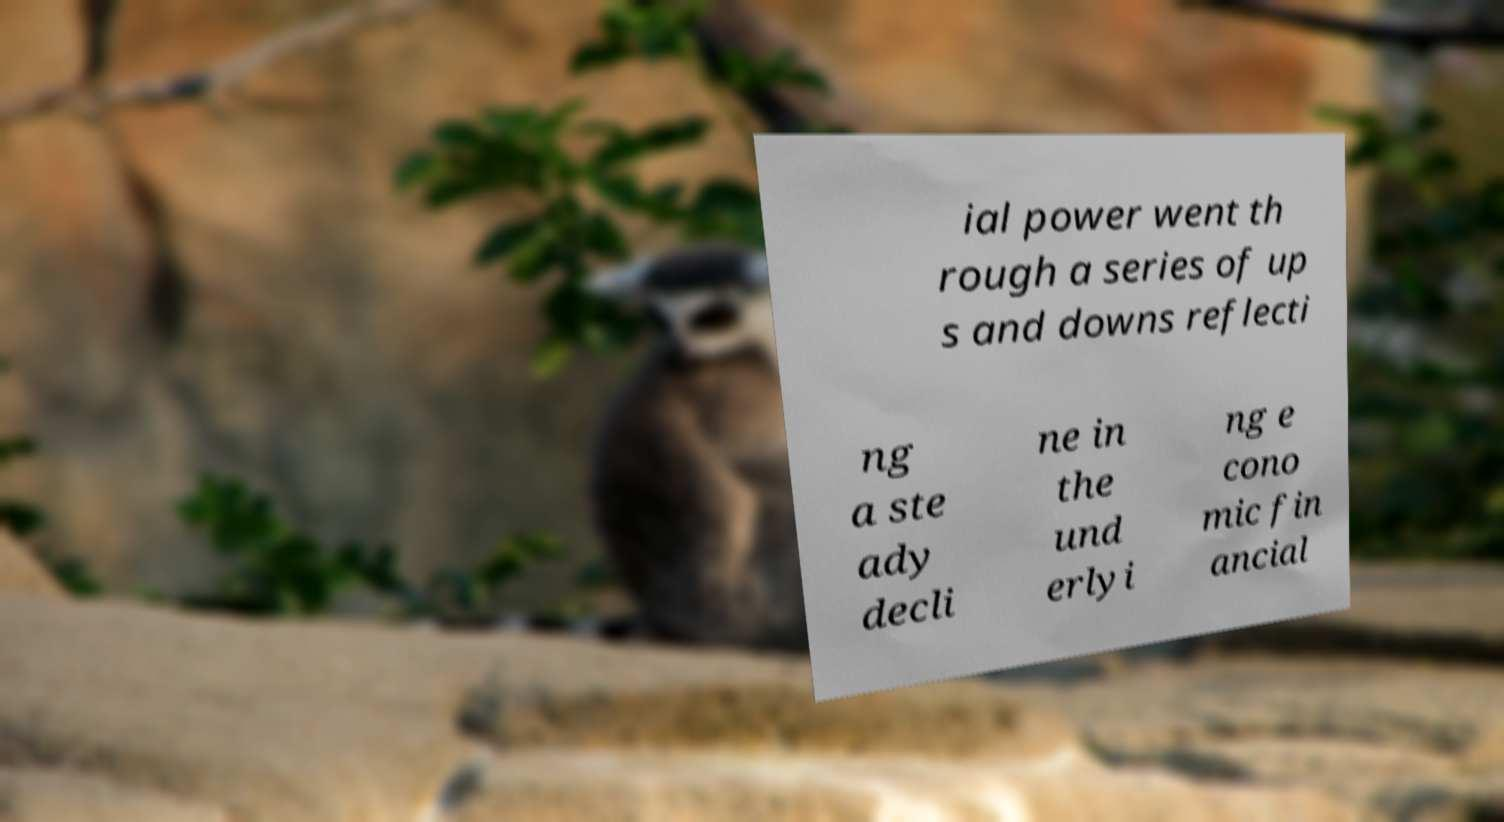Can you read and provide the text displayed in the image?This photo seems to have some interesting text. Can you extract and type it out for me? ial power went th rough a series of up s and downs reflecti ng a ste ady decli ne in the und erlyi ng e cono mic fin ancial 